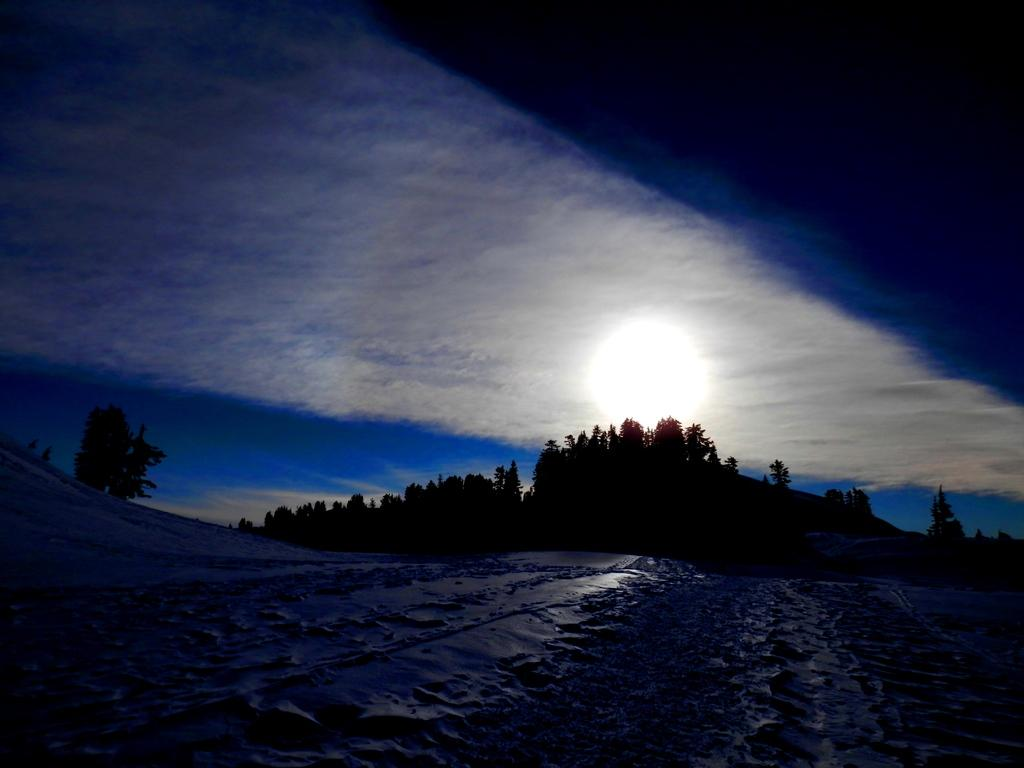What type of vegetation can be seen in the image? There are trees in the image. What is the source of light in the image? Moonlight is visible in the image. What is the condition of the sky in the image? The sky is cloudy in the image. Where is the cobweb located in the image? There is no cobweb present in the image. What type of arm can be seen in the image? There are no arms visible in the image; it features trees and a cloudy sky. 